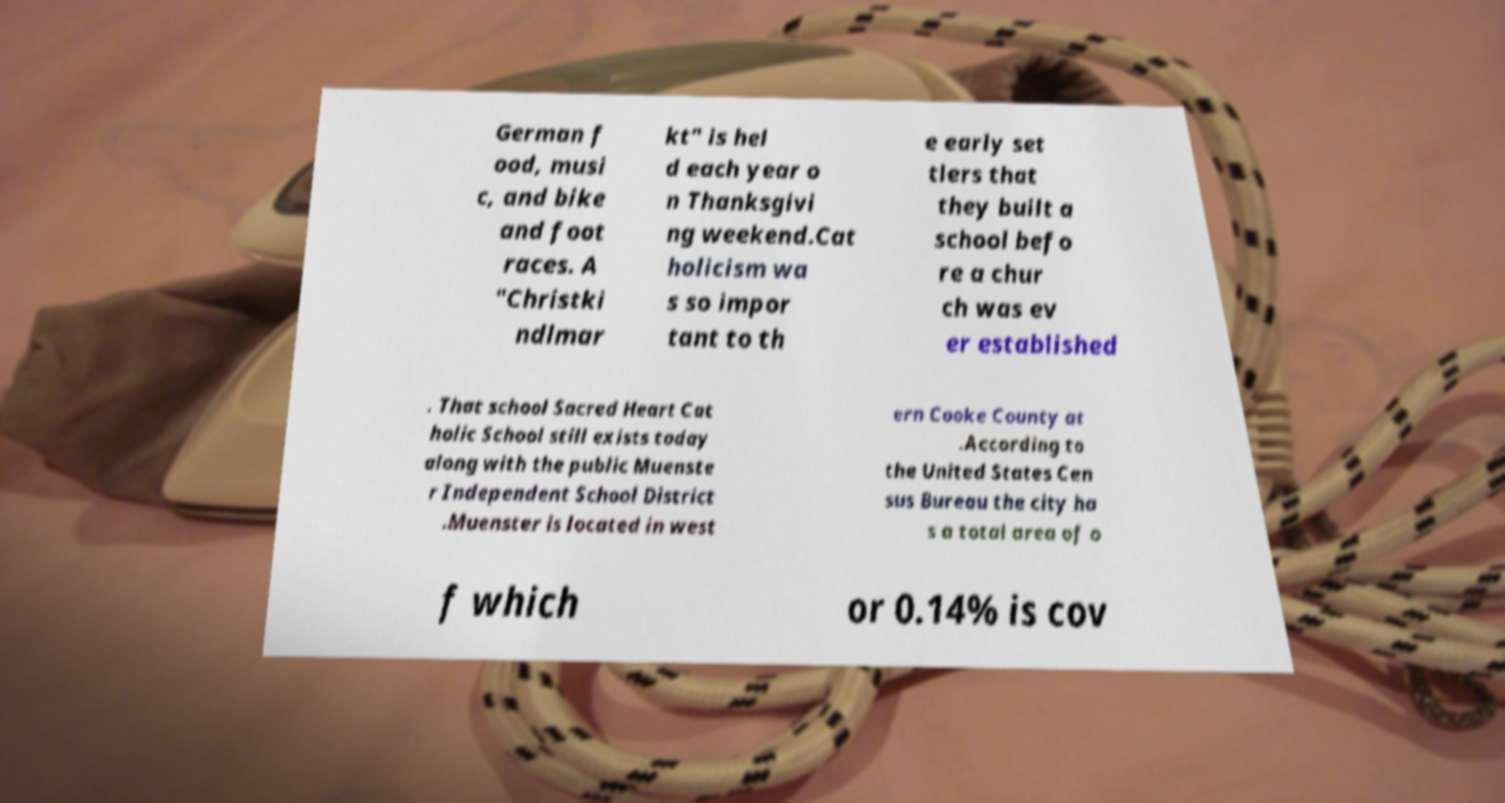Can you accurately transcribe the text from the provided image for me? German f ood, musi c, and bike and foot races. A "Christki ndlmar kt" is hel d each year o n Thanksgivi ng weekend.Cat holicism wa s so impor tant to th e early set tlers that they built a school befo re a chur ch was ev er established . That school Sacred Heart Cat holic School still exists today along with the public Muenste r Independent School District .Muenster is located in west ern Cooke County at .According to the United States Cen sus Bureau the city ha s a total area of o f which or 0.14% is cov 